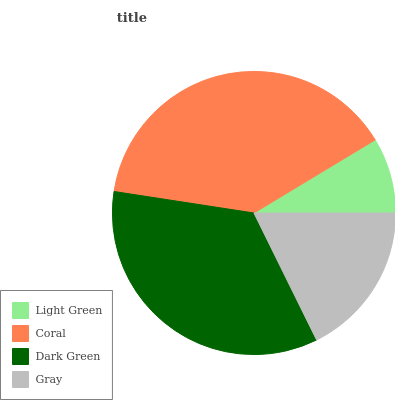Is Light Green the minimum?
Answer yes or no. Yes. Is Coral the maximum?
Answer yes or no. Yes. Is Dark Green the minimum?
Answer yes or no. No. Is Dark Green the maximum?
Answer yes or no. No. Is Coral greater than Dark Green?
Answer yes or no. Yes. Is Dark Green less than Coral?
Answer yes or no. Yes. Is Dark Green greater than Coral?
Answer yes or no. No. Is Coral less than Dark Green?
Answer yes or no. No. Is Dark Green the high median?
Answer yes or no. Yes. Is Gray the low median?
Answer yes or no. Yes. Is Coral the high median?
Answer yes or no. No. Is Coral the low median?
Answer yes or no. No. 